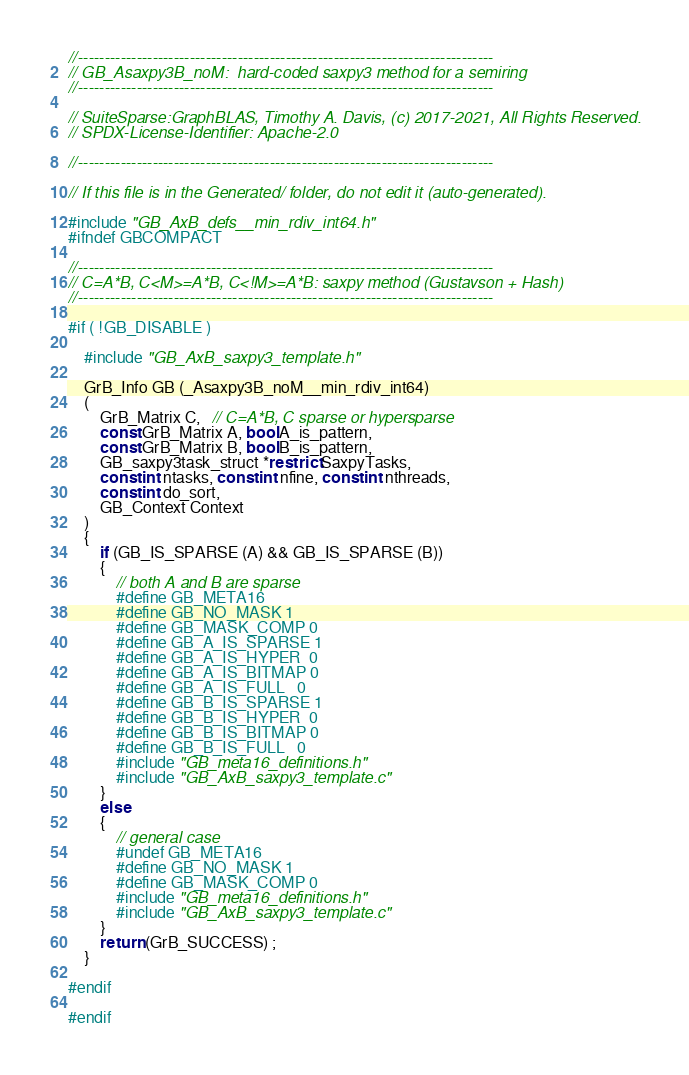Convert code to text. <code><loc_0><loc_0><loc_500><loc_500><_C_>//------------------------------------------------------------------------------
// GB_Asaxpy3B_noM:  hard-coded saxpy3 method for a semiring
//------------------------------------------------------------------------------

// SuiteSparse:GraphBLAS, Timothy A. Davis, (c) 2017-2021, All Rights Reserved.
// SPDX-License-Identifier: Apache-2.0

//------------------------------------------------------------------------------

// If this file is in the Generated/ folder, do not edit it (auto-generated).

#include "GB_AxB_defs__min_rdiv_int64.h"
#ifndef GBCOMPACT

//------------------------------------------------------------------------------
// C=A*B, C<M>=A*B, C<!M>=A*B: saxpy method (Gustavson + Hash)
//------------------------------------------------------------------------------

#if ( !GB_DISABLE )

    #include "GB_AxB_saxpy3_template.h"

    GrB_Info GB (_Asaxpy3B_noM__min_rdiv_int64)
    (
        GrB_Matrix C,   // C=A*B, C sparse or hypersparse
        const GrB_Matrix A, bool A_is_pattern,
        const GrB_Matrix B, bool B_is_pattern,
        GB_saxpy3task_struct *restrict SaxpyTasks,
        const int ntasks, const int nfine, const int nthreads,
        const int do_sort,
        GB_Context Context
    )
    {
        if (GB_IS_SPARSE (A) && GB_IS_SPARSE (B))
        {
            // both A and B are sparse
            #define GB_META16
            #define GB_NO_MASK 1
            #define GB_MASK_COMP 0
            #define GB_A_IS_SPARSE 1
            #define GB_A_IS_HYPER  0
            #define GB_A_IS_BITMAP 0
            #define GB_A_IS_FULL   0
            #define GB_B_IS_SPARSE 1
            #define GB_B_IS_HYPER  0
            #define GB_B_IS_BITMAP 0
            #define GB_B_IS_FULL   0
            #include "GB_meta16_definitions.h"
            #include "GB_AxB_saxpy3_template.c"
        }
        else
        {
            // general case
            #undef GB_META16
            #define GB_NO_MASK 1
            #define GB_MASK_COMP 0
            #include "GB_meta16_definitions.h"
            #include "GB_AxB_saxpy3_template.c"
        }
        return (GrB_SUCCESS) ;
    }

#endif

#endif

</code> 